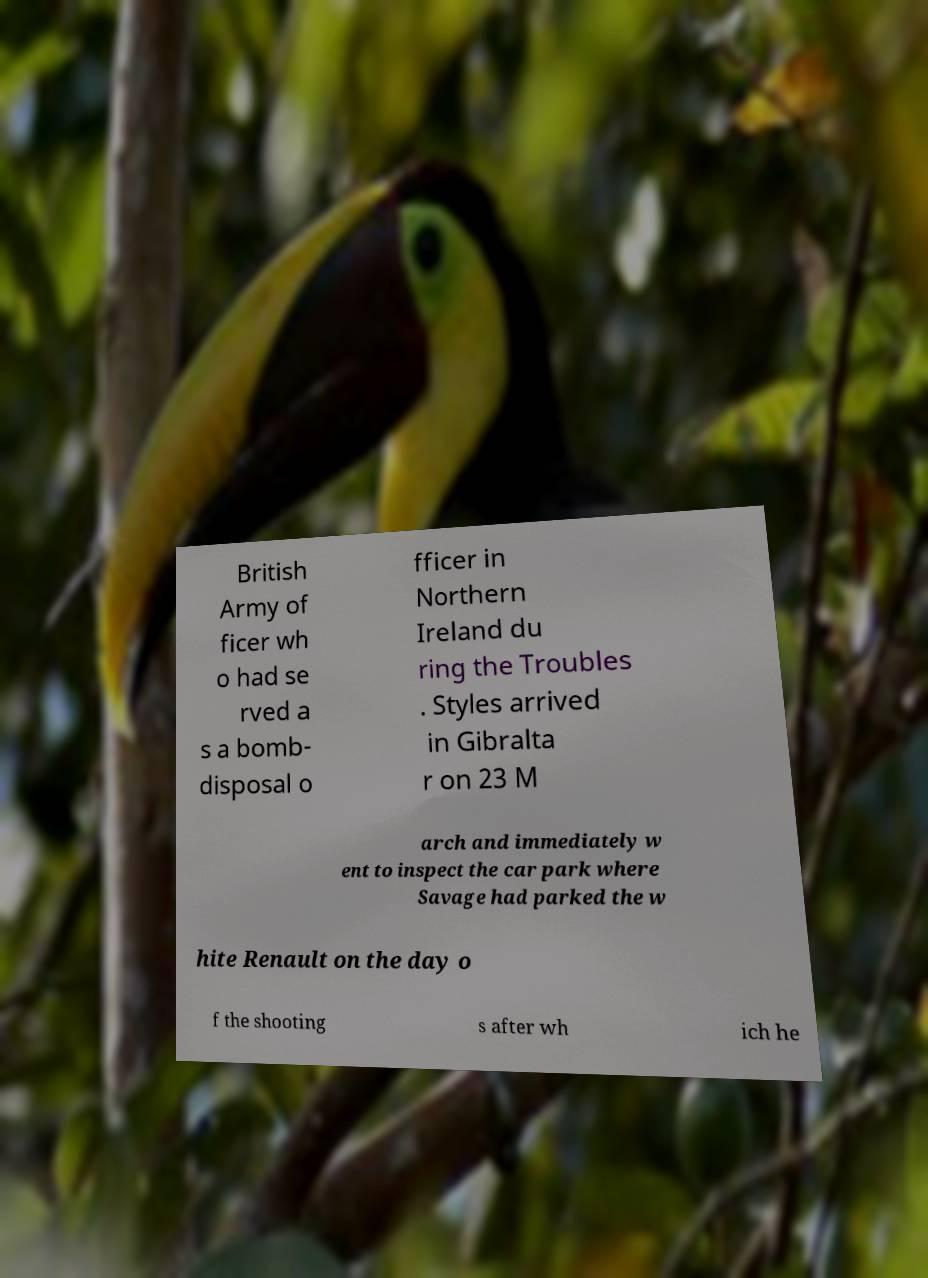Can you accurately transcribe the text from the provided image for me? British Army of ficer wh o had se rved a s a bomb- disposal o fficer in Northern Ireland du ring the Troubles . Styles arrived in Gibralta r on 23 M arch and immediately w ent to inspect the car park where Savage had parked the w hite Renault on the day o f the shooting s after wh ich he 